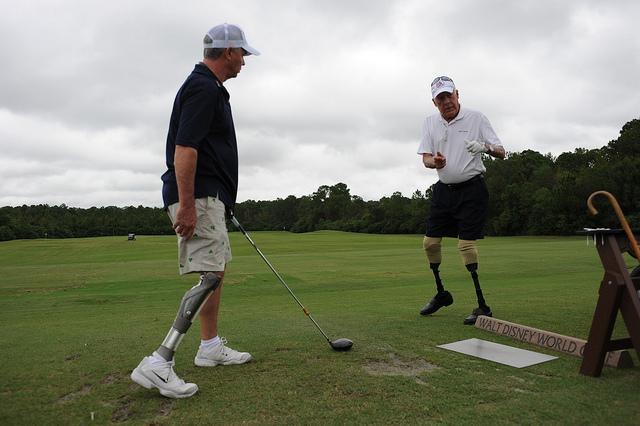How many people are there?
Give a very brief answer. 2. How many dolphins are painted on the boats in this photo?
Give a very brief answer. 0. 